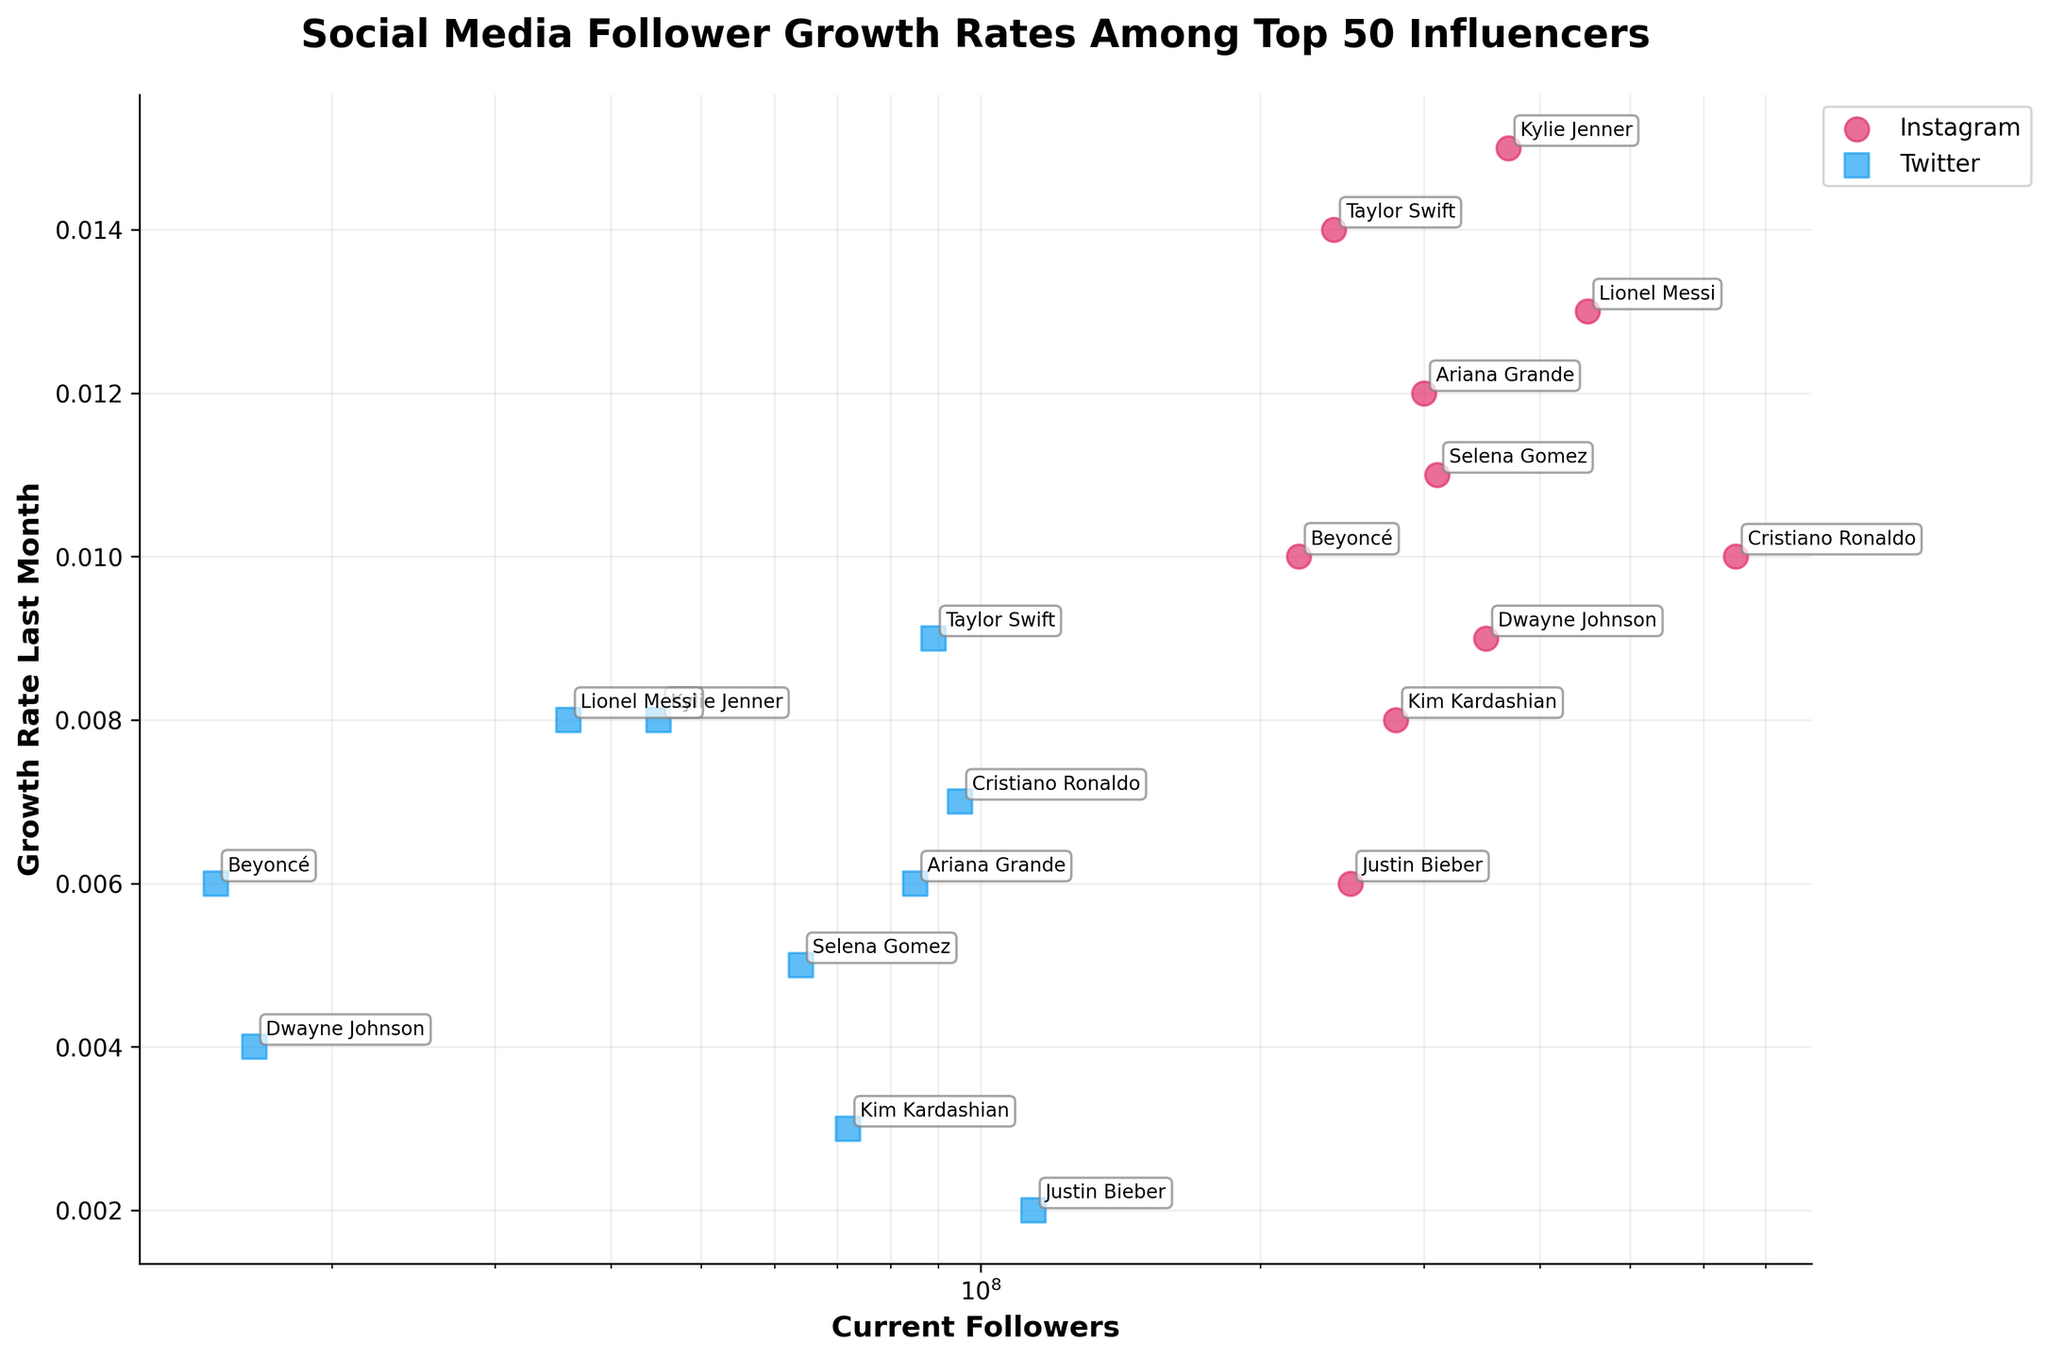What's the title of the figure? The title is usually displayed at the top of the figure. In this case, it is clearly labeled.
Answer: Social Media Follower Growth Rates Among Top 50 Influencers What is the axis label for the X-axis? The X-axis label is typically found along the horizontal axis. In this figure, it indicates the number of current followers.
Answer: Current Followers How many influencers are represented in the Instagram data points? By counting the number of data points that are color-coded for Instagram (which is pink), we can determine the number of Instagram influencers.
Answer: 10 Which influencer has the highest follower count on Instagram? To find the influencer with the highest follower count, we look for the highest value on the X-axis among the Instagram data points.
Answer: Cristiano Ronaldo What is the growth rate of Kylie Jenner on Twitter? Identify Kylie Jenner on the figure and check her growth rate on Twitter, which is color-coded in blue.
Answer: 0.008 Which platform has a higher average growth rate, Instagram or Twitter? Calculate the average growth rate for each platform by summing the growth rates and dividing by the number of influencers for that platform, then compare the averages.
Answer: Instagram Who has the slowest growth rate on Instagram among the given influencers? From the Instagram data points, search for the one with the lowest value on the Y-axis.
Answer: Justin Bieber What's the difference in growth rate between Taylor Swift on Instagram and Twitter? Look at Taylor Swift's growth rates on both platforms and subtract the Twitter rate from the Instagram rate.
Answer: 0.005 Is there any influencer whose growth rate is the same on both platforms? Compare the growth rates for each influencer on both platforms and check for any matches.
Answer: No How does the growth rate of Lionel Messi on Instagram compare to that on Twitter? Compare Lionel Messi's growth rates on both platforms by looking at their respective positions on the Y-axis.
Answer: Higher on Instagram 